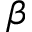<formula> <loc_0><loc_0><loc_500><loc_500>\beta</formula> 